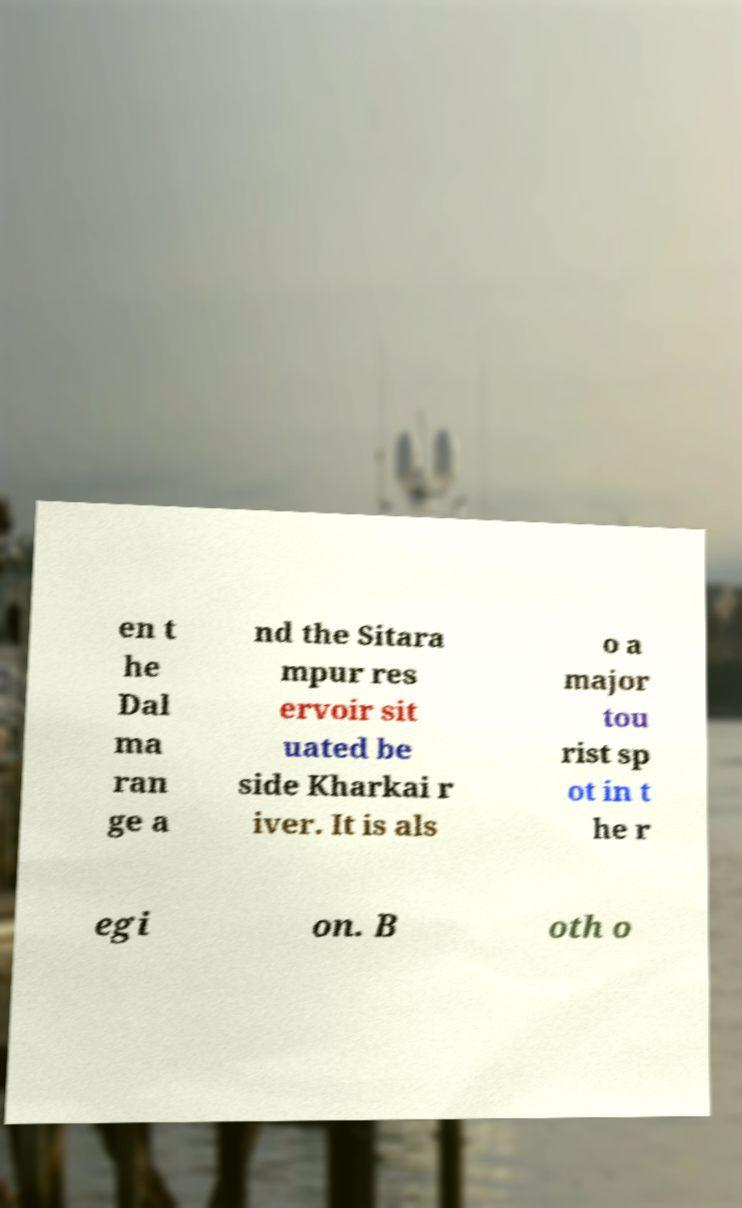What messages or text are displayed in this image? I need them in a readable, typed format. en t he Dal ma ran ge a nd the Sitara mpur res ervoir sit uated be side Kharkai r iver. It is als o a major tou rist sp ot in t he r egi on. B oth o 